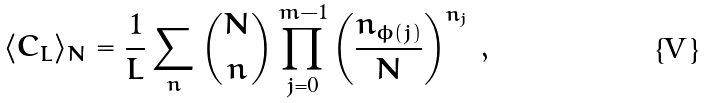Convert formula to latex. <formula><loc_0><loc_0><loc_500><loc_500>\langle C _ { L } \rangle _ { N } = \frac { 1 } { L } \sum _ { n } { N \choose n } \prod _ { j = 0 } ^ { m - 1 } \left ( \frac { n _ { \phi ( j ) } } N \right ) ^ { n _ { j } } \, ,</formula> 